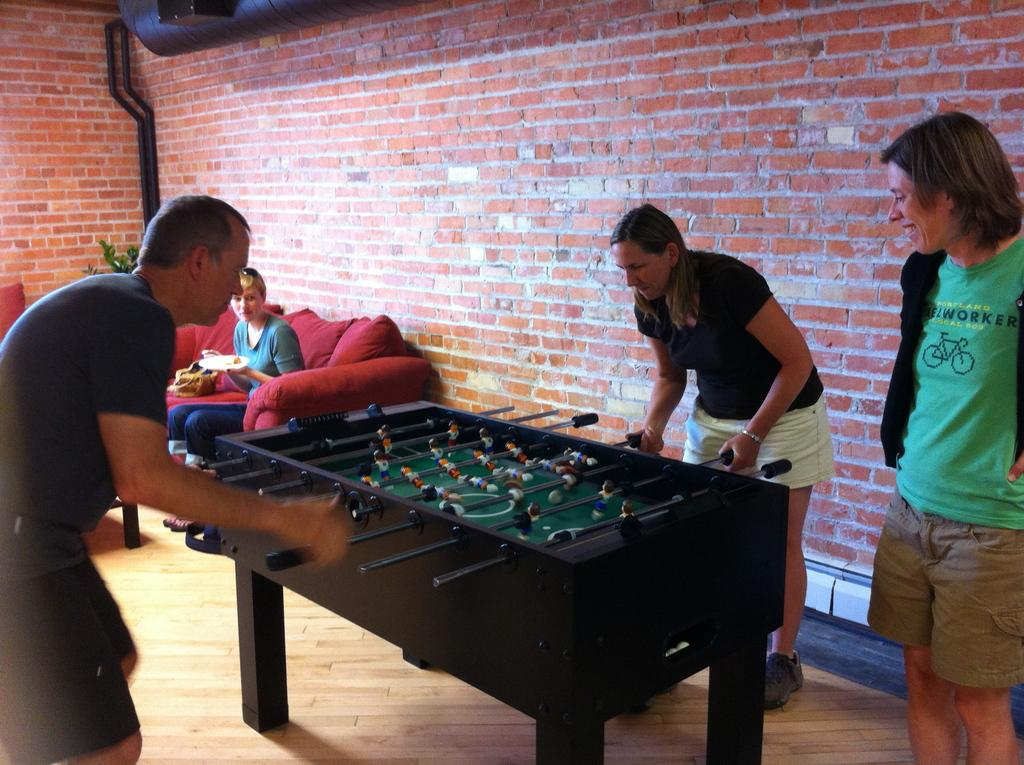What is the woman doing in the image? The woman is sitting on a couch in the image. What can be seen on the couch besides the woman? There are pillows on the couch. What activity are the two people engaged in? Two people are playing a game in the image. What is the position of the man in the image? There is a man standing in the image. What type of tin is the woman holding in the image? There is no tin present in the image; the woman is sitting on a couch with pillows. Can you see any wristbands on the people playing the game in the image? There is no mention of wristbands or any accessories on the people playing the game in the image. 